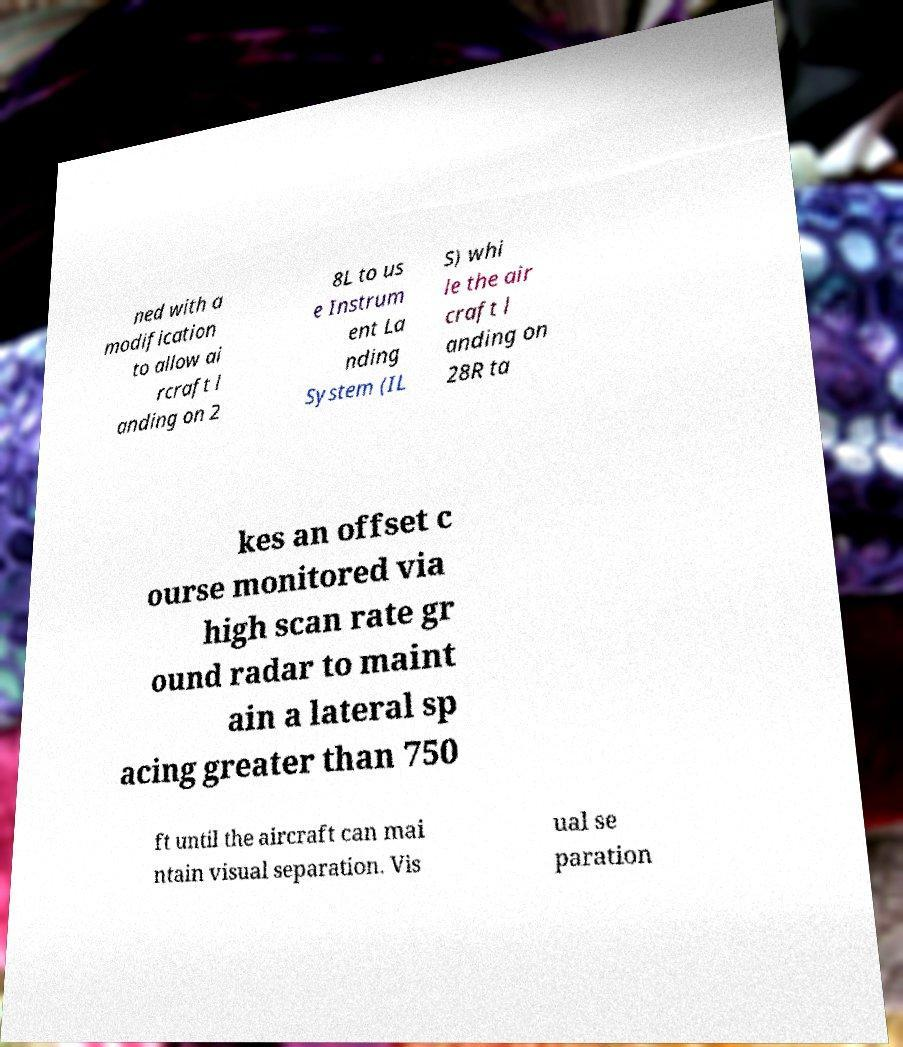There's text embedded in this image that I need extracted. Can you transcribe it verbatim? ned with a modification to allow ai rcraft l anding on 2 8L to us e Instrum ent La nding System (IL S) whi le the air craft l anding on 28R ta kes an offset c ourse monitored via high scan rate gr ound radar to maint ain a lateral sp acing greater than 750 ft until the aircraft can mai ntain visual separation. Vis ual se paration 